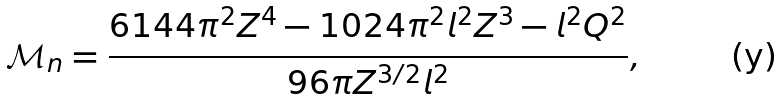Convert formula to latex. <formula><loc_0><loc_0><loc_500><loc_500>\mathcal { M } _ { n } = \frac { 6 1 4 4 \pi ^ { 2 } Z ^ { 4 } - 1 0 2 4 \pi ^ { 2 } l ^ { 2 } Z ^ { 3 } - l ^ { 2 } Q ^ { 2 } } { 9 6 \pi Z ^ { 3 / 2 } l ^ { 2 } } ,</formula> 